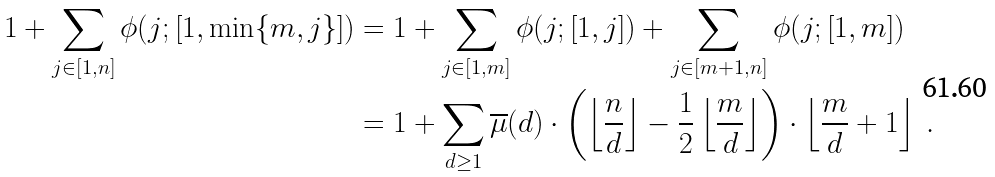<formula> <loc_0><loc_0><loc_500><loc_500>1 + \sum _ { j \in [ 1 , n ] } \phi ( j ; [ 1 , \min \{ m , j \} ] ) & = 1 + \sum _ { j \in [ 1 , m ] } \phi ( j ; [ 1 , j ] ) + \sum _ { j \in [ m + 1 , n ] } \phi ( j ; [ 1 , m ] ) \\ & = 1 + \sum _ { d \geq 1 } \overline { \mu } ( d ) \cdot \left ( \left \lfloor \frac { n } { d } \right \rfloor - \frac { 1 } { 2 } \left \lfloor \frac { m } { d } \right \rfloor \right ) \cdot \left \lfloor \frac { m } { d } + 1 \right \rfloor \ .</formula> 